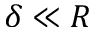Convert formula to latex. <formula><loc_0><loc_0><loc_500><loc_500>\delta \ll R</formula> 